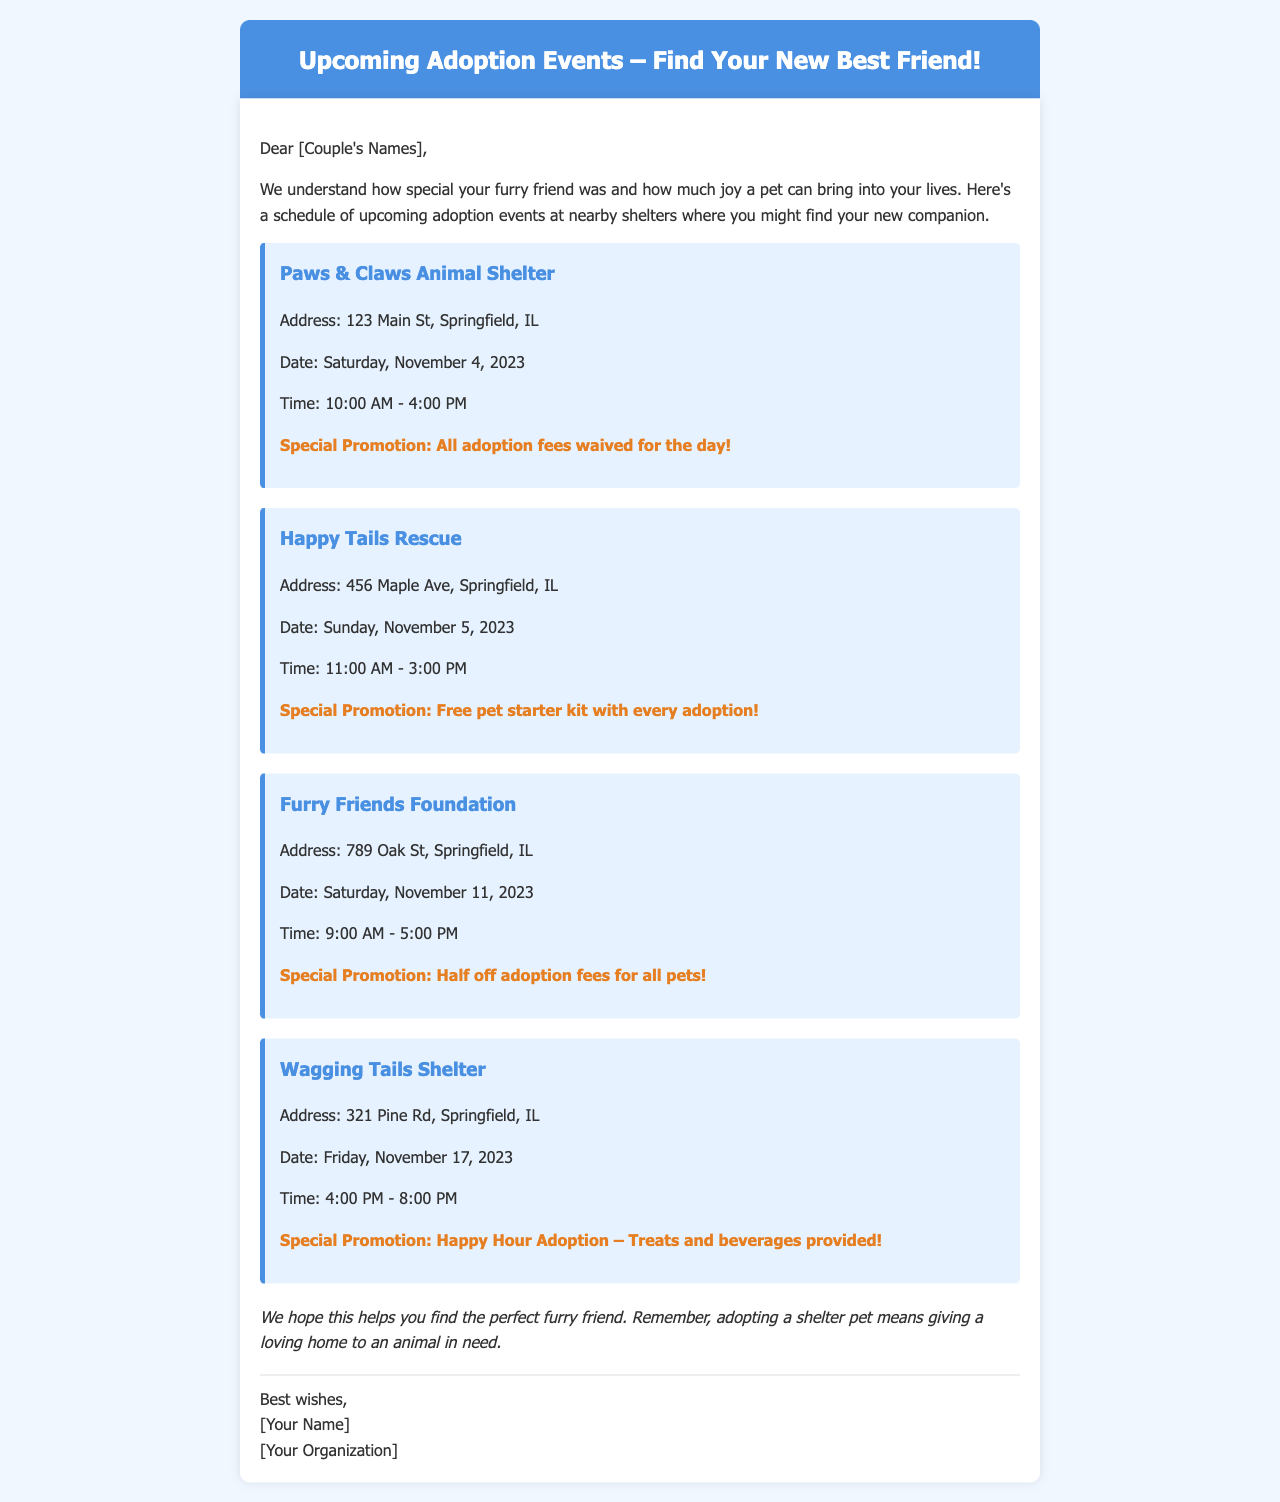What is the first adoption event? The first event mentioned in the document is at Paws & Claws Animal Shelter on November 4, 2023.
Answer: Paws & Claws Animal Shelter What is the address of Happy Tails Rescue? The address for Happy Tails Rescue is listed in the document as 456 Maple Ave, Springfield, IL.
Answer: 456 Maple Ave, Springfield, IL What special promotion is offered at Furry Friends Foundation? The document states that Furry Friends Foundation is offering half off adoption fees for all pets.
Answer: Half off adoption fees for all pets On which day is the Wagging Tails Shelter event scheduled? The document specifies that the Wagging Tails Shelter event is on Friday, November 17, 2023.
Answer: Friday, November 17, 2023 What are the operating hours for the Paws & Claws Animal Shelter event? According to the document, Paws & Claws Animal Shelter event operates from 10:00 AM to 4:00 PM.
Answer: 10:00 AM - 4:00 PM Which event offers a free pet starter kit? The document indicates that Happy Tails Rescue offers a free pet starter kit with every adoption.
Answer: Free pet starter kit with every adoption How many adoption events are listed in the document? The document lists a total of four adoption events at different shelters.
Answer: Four What is the closing remark in the email? The email concludes with a message about the importance of adopting a shelter pet.
Answer: We hope this helps you find the perfect furry friend 